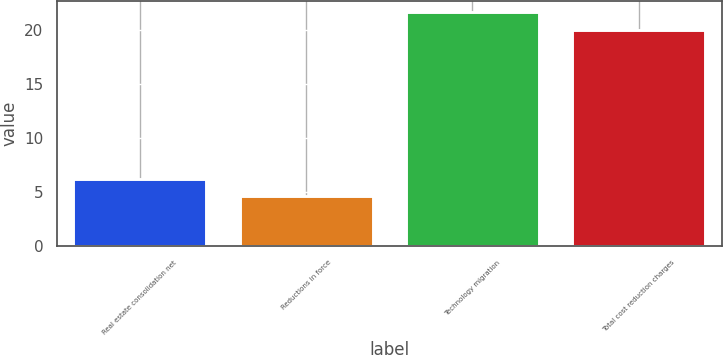<chart> <loc_0><loc_0><loc_500><loc_500><bar_chart><fcel>Real estate consolidation net<fcel>Reductions in force<fcel>Technology migration<fcel>Total cost reduction charges<nl><fcel>6.22<fcel>4.6<fcel>21.62<fcel>20<nl></chart> 